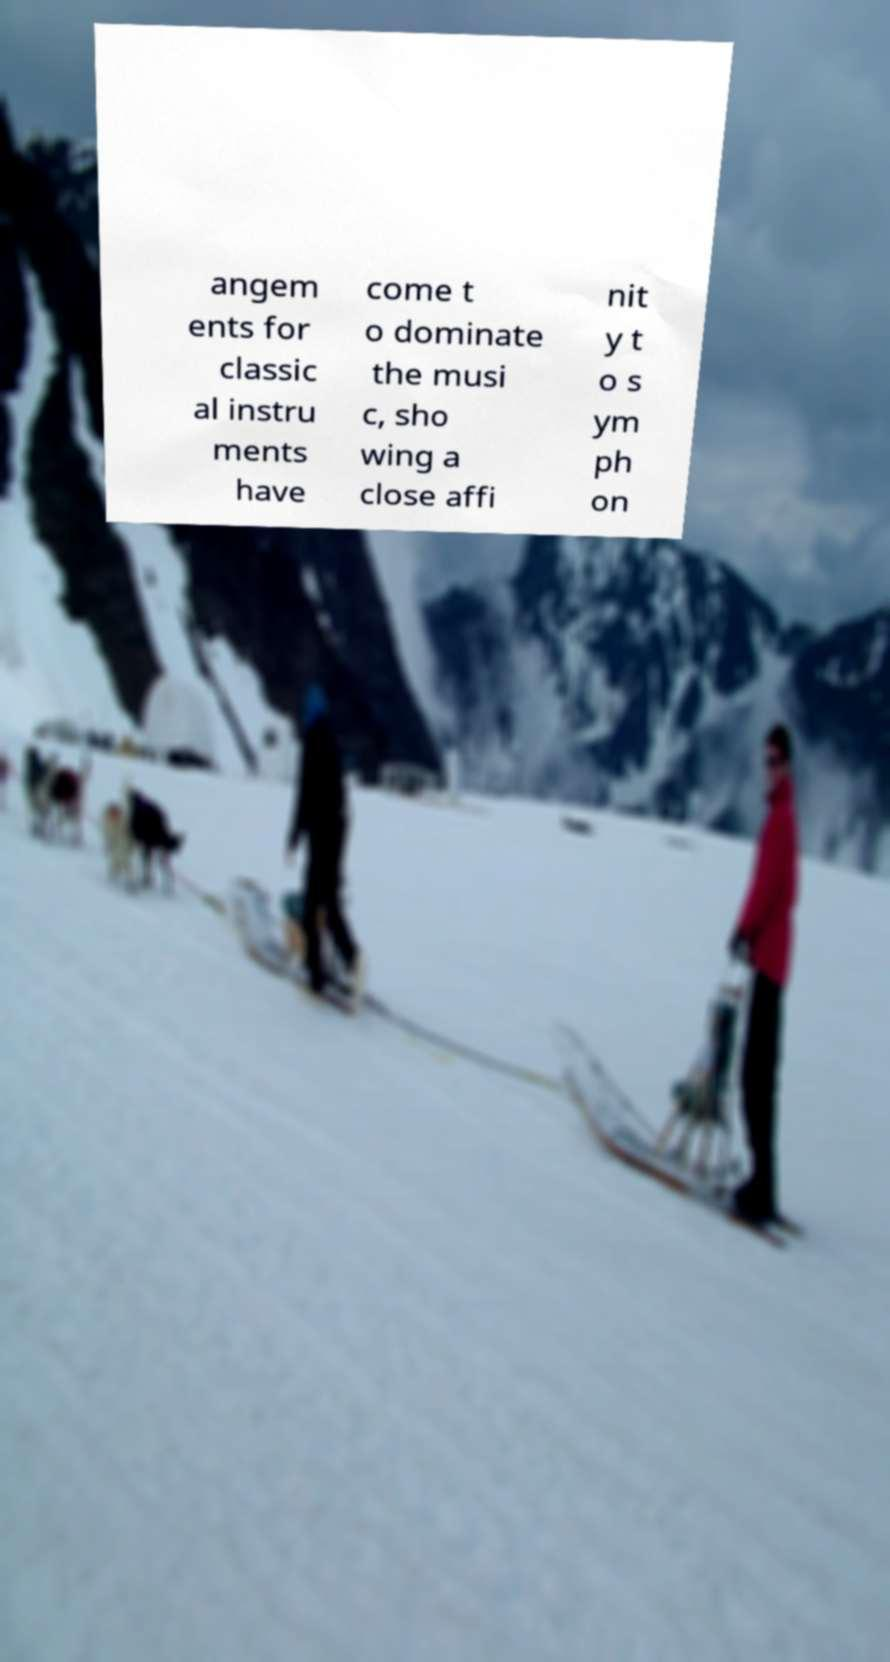There's text embedded in this image that I need extracted. Can you transcribe it verbatim? angem ents for classic al instru ments have come t o dominate the musi c, sho wing a close affi nit y t o s ym ph on 